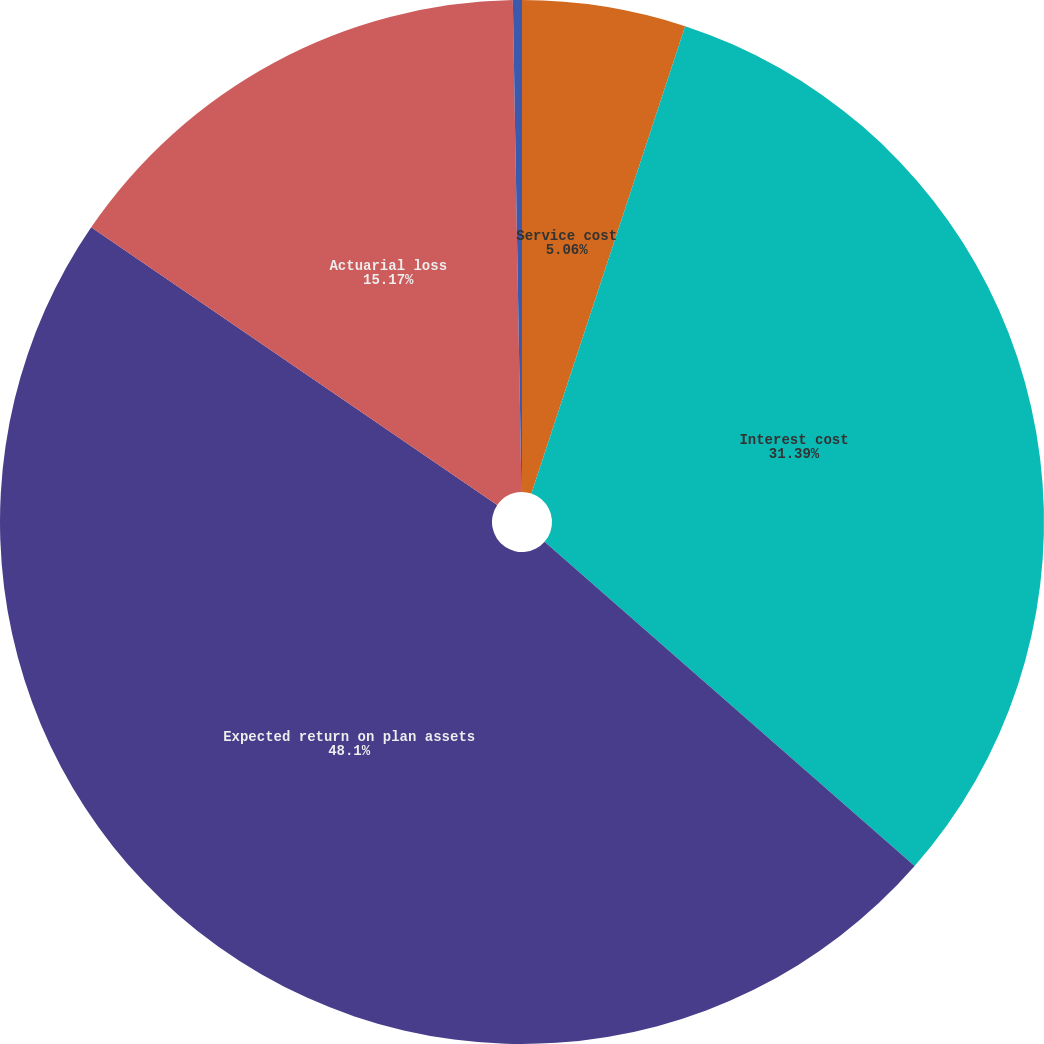Convert chart. <chart><loc_0><loc_0><loc_500><loc_500><pie_chart><fcel>Service cost<fcel>Interest cost<fcel>Expected return on plan assets<fcel>Actuarial loss<fcel>Net pension cost<nl><fcel>5.06%<fcel>31.39%<fcel>48.1%<fcel>15.17%<fcel>0.28%<nl></chart> 